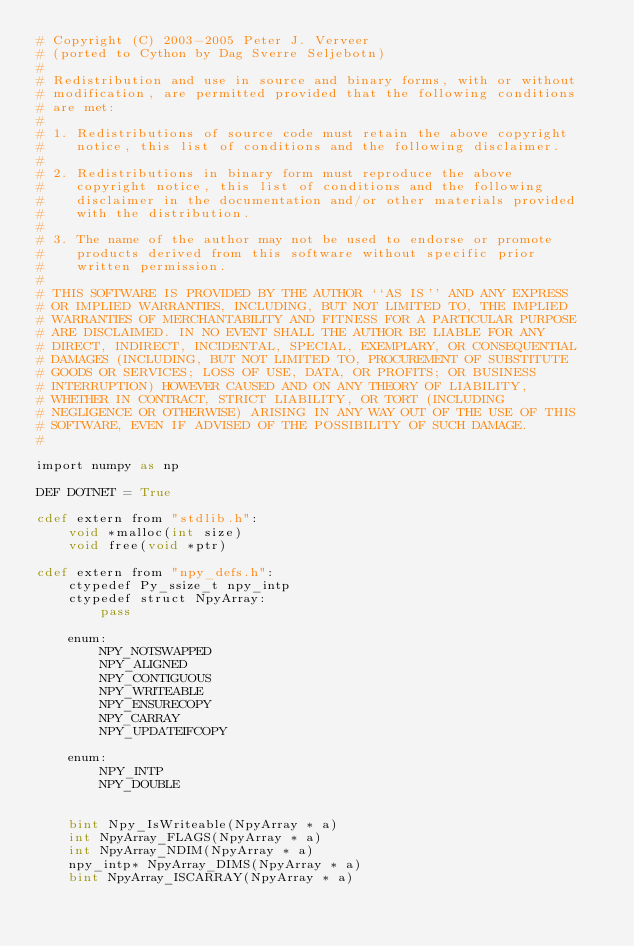<code> <loc_0><loc_0><loc_500><loc_500><_Cython_># Copyright (C) 2003-2005 Peter J. Verveer
# (ported to Cython by Dag Sverre Seljebotn)
#
# Redistribution and use in source and binary forms, with or without
# modification, are permitted provided that the following conditions
# are met:
#
# 1. Redistributions of source code must retain the above copyright
#    notice, this list of conditions and the following disclaimer.
#
# 2. Redistributions in binary form must reproduce the above
#    copyright notice, this list of conditions and the following
#    disclaimer in the documentation and/or other materials provided
#    with the distribution.
#
# 3. The name of the author may not be used to endorse or promote
#    products derived from this software without specific prior
#    written permission.
#
# THIS SOFTWARE IS PROVIDED BY THE AUTHOR ``AS IS'' AND ANY EXPRESS
# OR IMPLIED WARRANTIES, INCLUDING, BUT NOT LIMITED TO, THE IMPLIED
# WARRANTIES OF MERCHANTABILITY AND FITNESS FOR A PARTICULAR PURPOSE
# ARE DISCLAIMED. IN NO EVENT SHALL THE AUTHOR BE LIABLE FOR ANY
# DIRECT, INDIRECT, INCIDENTAL, SPECIAL, EXEMPLARY, OR CONSEQUENTIAL
# DAMAGES (INCLUDING, BUT NOT LIMITED TO, PROCUREMENT OF SUBSTITUTE
# GOODS OR SERVICES; LOSS OF USE, DATA, OR PROFITS; OR BUSINESS
# INTERRUPTION) HOWEVER CAUSED AND ON ANY THEORY OF LIABILITY,
# WHETHER IN CONTRACT, STRICT LIABILITY, OR TORT (INCLUDING
# NEGLIGENCE OR OTHERWISE) ARISING IN ANY WAY OUT OF THE USE OF THIS
# SOFTWARE, EVEN IF ADVISED OF THE POSSIBILITY OF SUCH DAMAGE.
#

import numpy as np

DEF DOTNET = True

cdef extern from "stdlib.h":
    void *malloc(int size)
    void free(void *ptr)
 
cdef extern from "npy_defs.h":
    ctypedef Py_ssize_t npy_intp
    ctypedef struct NpyArray:
        pass

    enum:
        NPY_NOTSWAPPED
        NPY_ALIGNED
        NPY_CONTIGUOUS
        NPY_WRITEABLE
        NPY_ENSURECOPY
        NPY_CARRAY
        NPY_UPDATEIFCOPY

    enum:
        NPY_INTP
        NPY_DOUBLE

        
    bint Npy_IsWriteable(NpyArray * a)
    int NpyArray_FLAGS(NpyArray * a)
    int NpyArray_NDIM(NpyArray * a)
    npy_intp* NpyArray_DIMS(NpyArray * a)
    bint NpyArray_ISCARRAY(NpyArray * a)</code> 